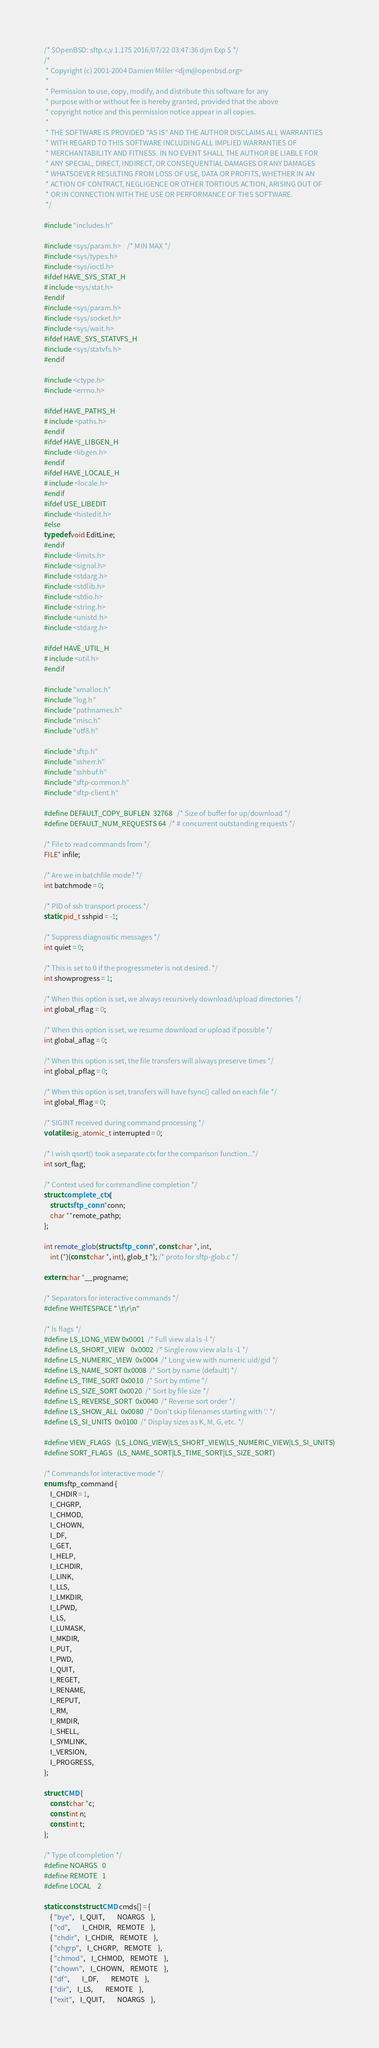<code> <loc_0><loc_0><loc_500><loc_500><_C_>/* $OpenBSD: sftp.c,v 1.175 2016/07/22 03:47:36 djm Exp $ */
/*
 * Copyright (c) 2001-2004 Damien Miller <djm@openbsd.org>
 *
 * Permission to use, copy, modify, and distribute this software for any
 * purpose with or without fee is hereby granted, provided that the above
 * copyright notice and this permission notice appear in all copies.
 *
 * THE SOFTWARE IS PROVIDED "AS IS" AND THE AUTHOR DISCLAIMS ALL WARRANTIES
 * WITH REGARD TO THIS SOFTWARE INCLUDING ALL IMPLIED WARRANTIES OF
 * MERCHANTABILITY AND FITNESS. IN NO EVENT SHALL THE AUTHOR BE LIABLE FOR
 * ANY SPECIAL, DIRECT, INDIRECT, OR CONSEQUENTIAL DAMAGES OR ANY DAMAGES
 * WHATSOEVER RESULTING FROM LOSS OF USE, DATA OR PROFITS, WHETHER IN AN
 * ACTION OF CONTRACT, NEGLIGENCE OR OTHER TORTIOUS ACTION, ARISING OUT OF
 * OR IN CONNECTION WITH THE USE OR PERFORMANCE OF THIS SOFTWARE.
 */

#include "includes.h"

#include <sys/param.h>	/* MIN MAX */
#include <sys/types.h>
#include <sys/ioctl.h>
#ifdef HAVE_SYS_STAT_H
# include <sys/stat.h>
#endif
#include <sys/param.h>
#include <sys/socket.h>
#include <sys/wait.h>
#ifdef HAVE_SYS_STATVFS_H
#include <sys/statvfs.h>
#endif

#include <ctype.h>
#include <errno.h>

#ifdef HAVE_PATHS_H
# include <paths.h>
#endif
#ifdef HAVE_LIBGEN_H
#include <libgen.h>
#endif
#ifdef HAVE_LOCALE_H
# include <locale.h>
#endif
#ifdef USE_LIBEDIT
#include <histedit.h>
#else
typedef void EditLine;
#endif
#include <limits.h>
#include <signal.h>
#include <stdarg.h>
#include <stdlib.h>
#include <stdio.h>
#include <string.h>
#include <unistd.h>
#include <stdarg.h>

#ifdef HAVE_UTIL_H
# include <util.h>
#endif

#include "xmalloc.h"
#include "log.h"
#include "pathnames.h"
#include "misc.h"
#include "utf8.h"

#include "sftp.h"
#include "ssherr.h"
#include "sshbuf.h"
#include "sftp-common.h"
#include "sftp-client.h"

#define DEFAULT_COPY_BUFLEN	32768	/* Size of buffer for up/download */
#define DEFAULT_NUM_REQUESTS	64	/* # concurrent outstanding requests */

/* File to read commands from */
FILE* infile;

/* Are we in batchfile mode? */
int batchmode = 0;

/* PID of ssh transport process */
static pid_t sshpid = -1;

/* Suppress diagnositic messages */
int quiet = 0;

/* This is set to 0 if the progressmeter is not desired. */
int showprogress = 1;

/* When this option is set, we always recursively download/upload directories */
int global_rflag = 0;

/* When this option is set, we resume download or upload if possible */
int global_aflag = 0;

/* When this option is set, the file transfers will always preserve times */
int global_pflag = 0;

/* When this option is set, transfers will have fsync() called on each file */
int global_fflag = 0;

/* SIGINT received during command processing */
volatile sig_atomic_t interrupted = 0;

/* I wish qsort() took a separate ctx for the comparison function...*/
int sort_flag;

/* Context used for commandline completion */
struct complete_ctx {
	struct sftp_conn *conn;
	char **remote_pathp;
};

int remote_glob(struct sftp_conn *, const char *, int,
    int (*)(const char *, int), glob_t *); /* proto for sftp-glob.c */

extern char *__progname;

/* Separators for interactive commands */
#define WHITESPACE " \t\r\n"

/* ls flags */
#define LS_LONG_VIEW	0x0001	/* Full view ala ls -l */
#define LS_SHORT_VIEW	0x0002	/* Single row view ala ls -1 */
#define LS_NUMERIC_VIEW	0x0004	/* Long view with numeric uid/gid */
#define LS_NAME_SORT	0x0008	/* Sort by name (default) */
#define LS_TIME_SORT	0x0010	/* Sort by mtime */
#define LS_SIZE_SORT	0x0020	/* Sort by file size */
#define LS_REVERSE_SORT	0x0040	/* Reverse sort order */
#define LS_SHOW_ALL	0x0080	/* Don't skip filenames starting with '.' */
#define LS_SI_UNITS	0x0100	/* Display sizes as K, M, G, etc. */

#define VIEW_FLAGS	(LS_LONG_VIEW|LS_SHORT_VIEW|LS_NUMERIC_VIEW|LS_SI_UNITS)
#define SORT_FLAGS	(LS_NAME_SORT|LS_TIME_SORT|LS_SIZE_SORT)

/* Commands for interactive mode */
enum sftp_command {
	I_CHDIR = 1,
	I_CHGRP,
	I_CHMOD,
	I_CHOWN,
	I_DF,
	I_GET,
	I_HELP,
	I_LCHDIR,
	I_LINK,
	I_LLS,
	I_LMKDIR,
	I_LPWD,
	I_LS,
	I_LUMASK,
	I_MKDIR,
	I_PUT,
	I_PWD,
	I_QUIT,
	I_REGET,
	I_RENAME,
	I_REPUT,
	I_RM,
	I_RMDIR,
	I_SHELL,
	I_SYMLINK,
	I_VERSION,
	I_PROGRESS,
};

struct CMD {
	const char *c;
	const int n;
	const int t;
};

/* Type of completion */
#define NOARGS	0
#define REMOTE	1
#define LOCAL	2

static const struct CMD cmds[] = {
	{ "bye",	I_QUIT,		NOARGS	},
	{ "cd",		I_CHDIR,	REMOTE	},
	{ "chdir",	I_CHDIR,	REMOTE	},
	{ "chgrp",	I_CHGRP,	REMOTE	},
	{ "chmod",	I_CHMOD,	REMOTE	},
	{ "chown",	I_CHOWN,	REMOTE	},
	{ "df",		I_DF,		REMOTE	},
	{ "dir",	I_LS,		REMOTE	},
	{ "exit",	I_QUIT,		NOARGS	},</code> 